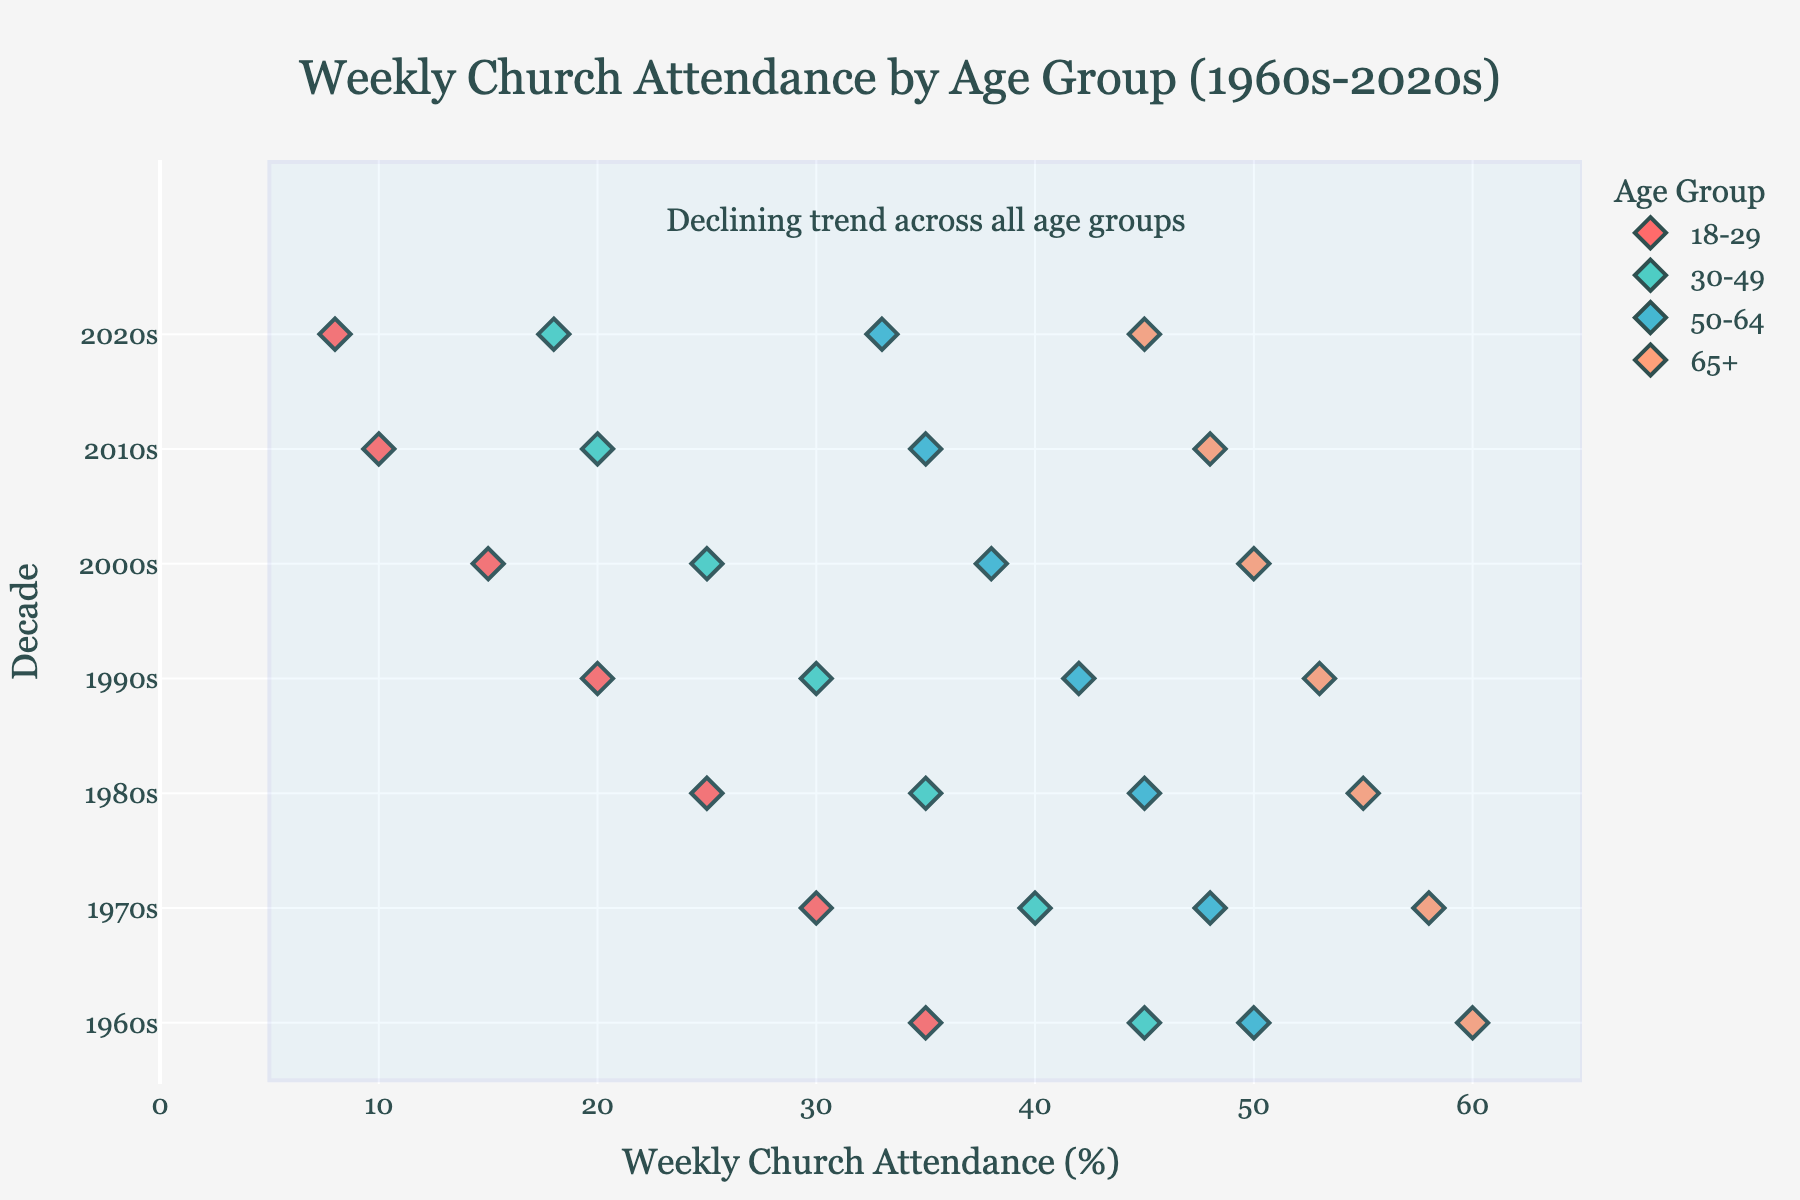Which age group had the highest weekly church attendance in the 1960s? By observing the plot, the age group '65+' had the highest weekly church attendance in the 1960s as indicated by the highest value on the vertical axis for that decade.
Answer: 65+ What is the overall trend in weekly church attendance over the decades across all age groups? The plot shows a declining trend in weekly church attendance across all age groups from the 1960s to the 2020s.
Answer: Declining Which age group had a 45% weekly church attendance rate in the 2020s? By examining the markers and their percentage levels, the age group '65+' had a 45% weekly church attendance rate in the 2020s.
Answer: 65+ How much did the weekly church attendance for the 18-29 age group decrease from the 1960s to the 2020s? The attendance for the 18-29 age group was 35% in the 1960s and decreased to 8% in the 2020s. The difference is calculated as 35 - 8 = 27%.
Answer: 27% Compare the church attendance between the 30-49 age group and the 50-64 age group in the 1980s. Which group attended more frequently? Looking at the plot for the 1980s, the 50-64 age group attended more frequently with 45% compared to the 30-49 age group with 35%.
Answer: 50-64 What is the difference in church attendance between the 18-29 and 30-49 age groups in the 2020s? In the 2020s, the 18-29 group had 8% attendance while the 30-49 group had 18%, giving a difference of 18 - 8 = 10%.
Answer: 10% What is the range of weekly church attendance percentages for the 30-49 age group across all decades? The maximum attendance for the 30-49 age group is 45% in the 1960s, and the minimum is 18% in the 2020s, giving a range of 45 - 18 = 27%.
Answer: 27% Which decade shows the steepest decline in church attendance for the 65+ age group? From observing the plot, the largest drop for the 65+ age group occurred between the 2000s (50%) and the 2010s (48%), a decrease of 2 percentage points. However, it is more practical to compare this relative to the initial values of each decade to determine the steepest fall. The drop from 48% to 45% in the 2020s gives a proportionally significant decrease.
Answer: 2020s 